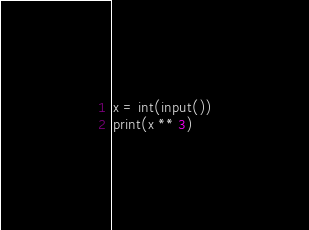<code> <loc_0><loc_0><loc_500><loc_500><_Python_>x = int(input())
print(x ** 3)</code> 